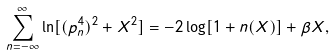<formula> <loc_0><loc_0><loc_500><loc_500>\sum _ { n = - \infty } ^ { \infty } \ln [ ( p ^ { 4 } _ { n } ) ^ { 2 } + X ^ { 2 } ] = - 2 \log [ 1 + n ( X ) ] + \beta X ,</formula> 